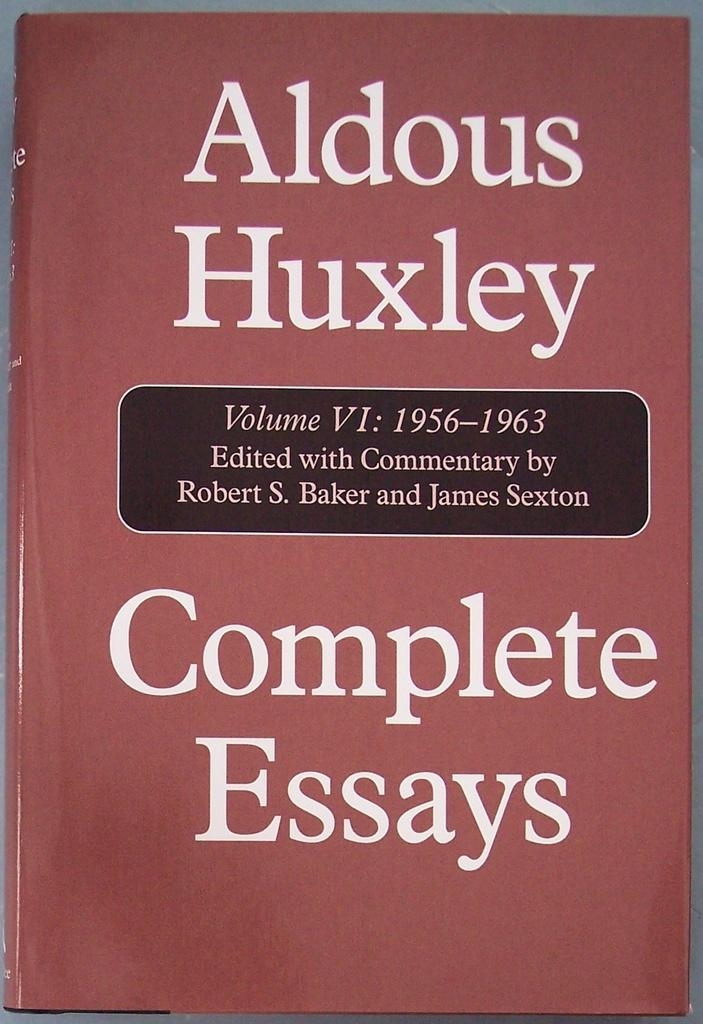<image>
Present a compact description of the photo's key features. An essay book has a red cover and is volume VI. 